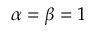Convert formula to latex. <formula><loc_0><loc_0><loc_500><loc_500>\alpha = \beta = 1</formula> 